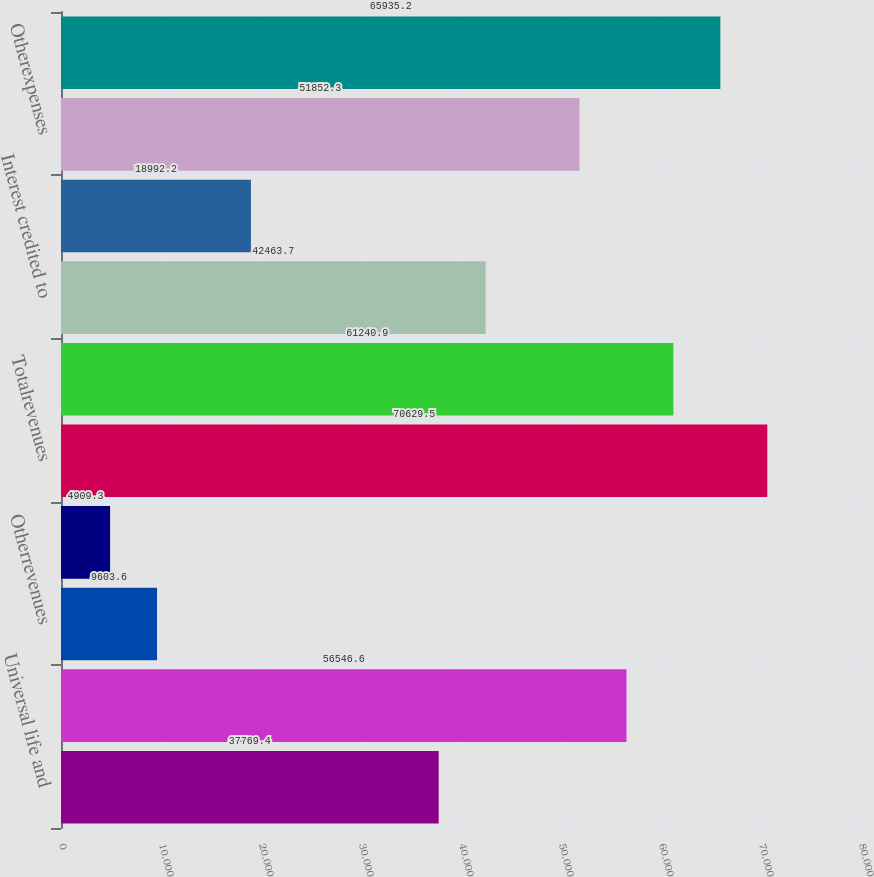<chart> <loc_0><loc_0><loc_500><loc_500><bar_chart><fcel>Universal life and<fcel>Netinvestmentincome<fcel>Otherrevenues<fcel>Netinvestmentgains(losses)<fcel>Totalrevenues<fcel>Policyholderbenefitsandclaims<fcel>Interest credited to<fcel>Policyholderdividends<fcel>Otherexpenses<fcel>Totalexpenses<nl><fcel>37769.4<fcel>56546.6<fcel>9603.6<fcel>4909.3<fcel>70629.5<fcel>61240.9<fcel>42463.7<fcel>18992.2<fcel>51852.3<fcel>65935.2<nl></chart> 